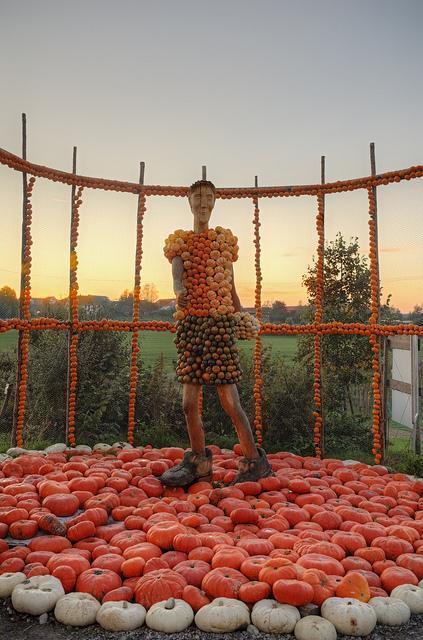How many oranges are there?
Give a very brief answer. 2. How many yellow bottles are there?
Give a very brief answer. 0. 